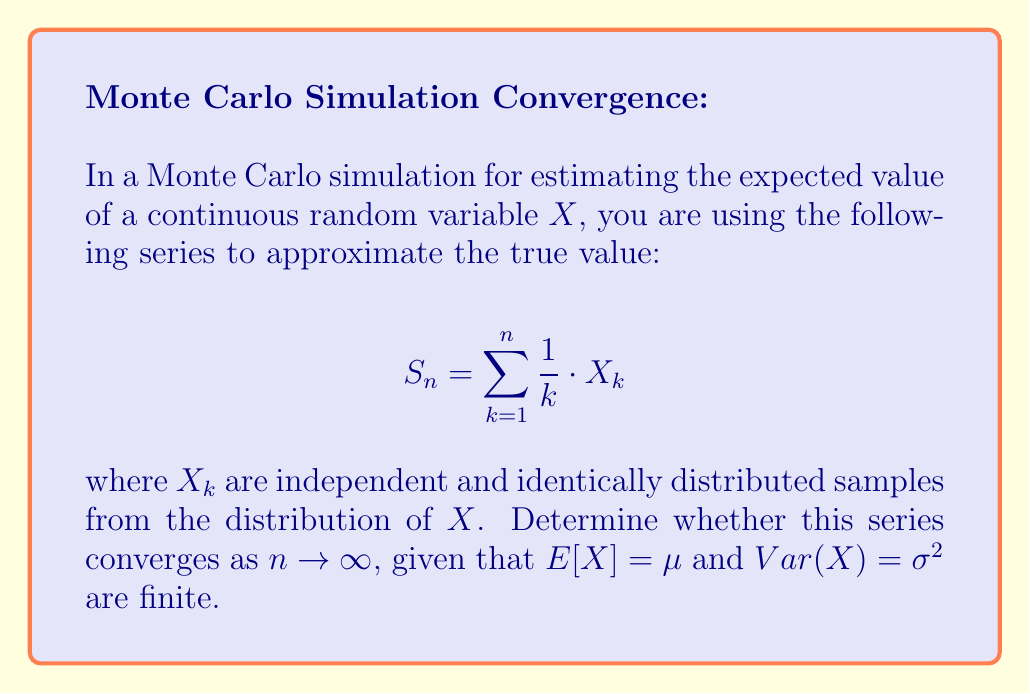Can you solve this math problem? To determine the convergence of this series, we'll follow these steps:

1) First, let's consider the expected value of $S_n$:

   $$E[S_n] = E\left[\sum_{k=1}^n \frac{1}{k} \cdot X_k\right] = \sum_{k=1}^n \frac{1}{k} \cdot E[X_k] = \mu \sum_{k=1}^n \frac{1}{k}$$

2) The series $\sum_{k=1}^n \frac{1}{k}$ is the harmonic series, which diverges as $n \to \infty$. Therefore, $E[S_n]$ diverges.

3) Next, let's consider the variance of $S_n$:

   $$Var(S_n) = Var\left(\sum_{k=1}^n \frac{1}{k} \cdot X_k\right) = \sum_{k=1}^n \frac{1}{k^2} \cdot Var(X_k) = \sigma^2 \sum_{k=1}^n \frac{1}{k^2}$$

4) The series $\sum_{k=1}^n \frac{1}{k^2}$ is the p-series with $p=2$, which converges to $\frac{\pi^2}{6}$ as $n \to \infty$. Therefore, $Var(S_n)$ converges to a finite value.

5) By the Strong Law of Large Numbers, we know that:

   $$\lim_{n \to \infty} \frac{S_n}{H_n} = \mu \text{ almost surely}$$

   where $H_n = \sum_{k=1}^n \frac{1}{k}$ is the nth harmonic number.

6) However, $H_n \to \infty$ as $n \to \infty$, which means $S_n$ also diverges almost surely.

Therefore, the series $S_n$ does not converge as $n \to \infty$. It diverges almost surely, although its variance remains finite.
Answer: The series diverges. 